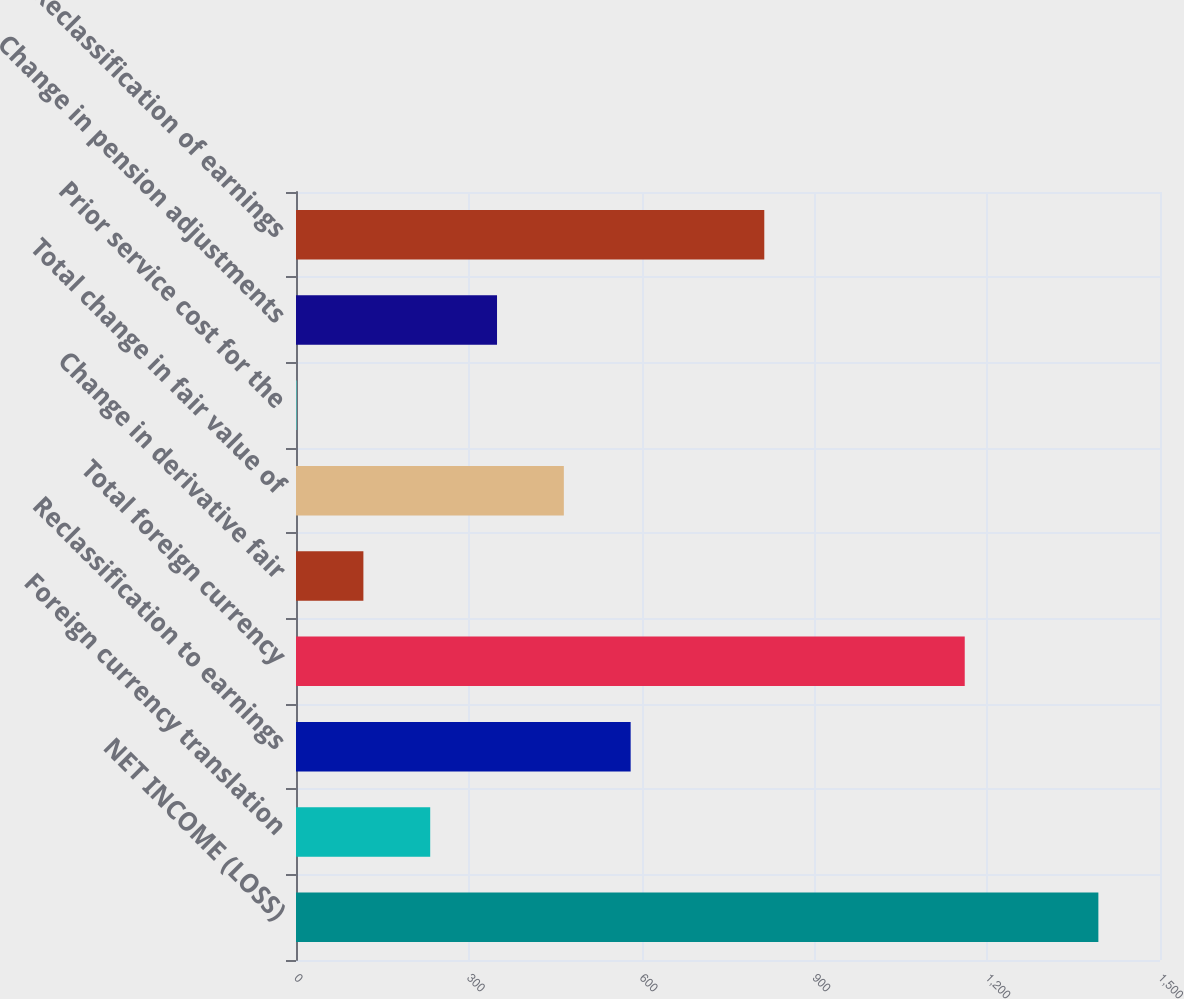<chart> <loc_0><loc_0><loc_500><loc_500><bar_chart><fcel>NET INCOME (LOSS)<fcel>Foreign currency translation<fcel>Reclassification to earnings<fcel>Total foreign currency<fcel>Change in derivative fair<fcel>Total change in fair value of<fcel>Prior service cost for the<fcel>Change in pension adjustments<fcel>Reclassification of earnings<nl><fcel>1393<fcel>233<fcel>581<fcel>1161<fcel>117<fcel>465<fcel>1<fcel>349<fcel>813<nl></chart> 